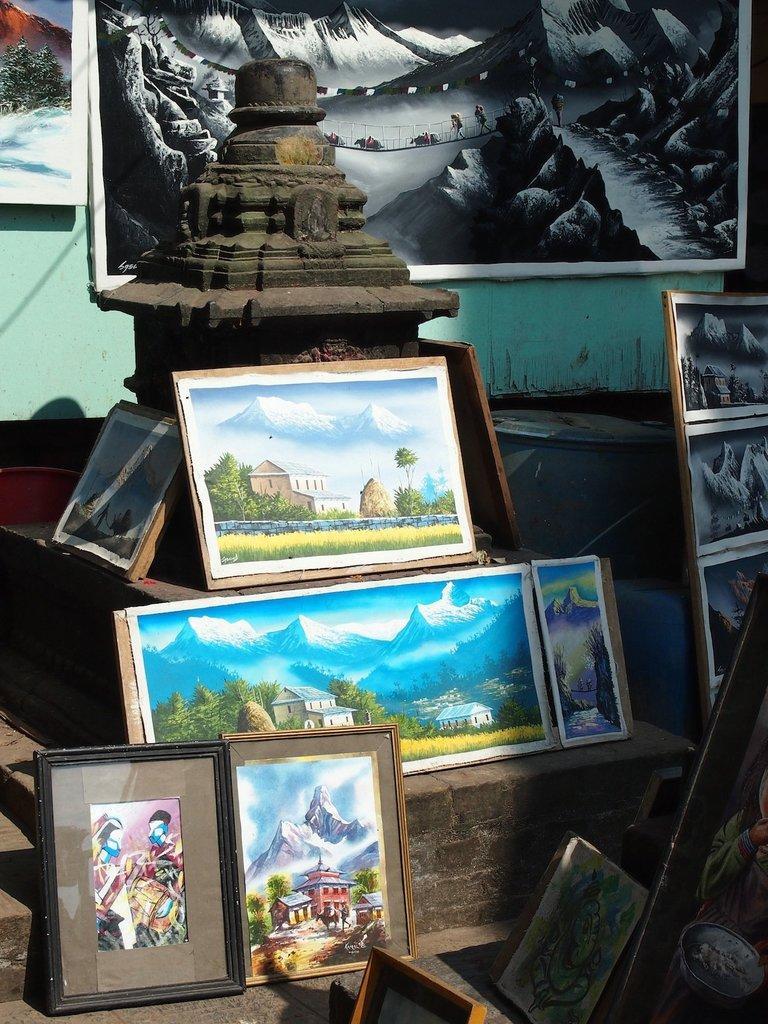Please provide a concise description of this image. In this picture, we see many photo frames which are placed on a table like. Behind that, we see a pillar and we even see photo frames which are placed on the green wall. This picture might be clicked outside the city and it is a sunny day. 